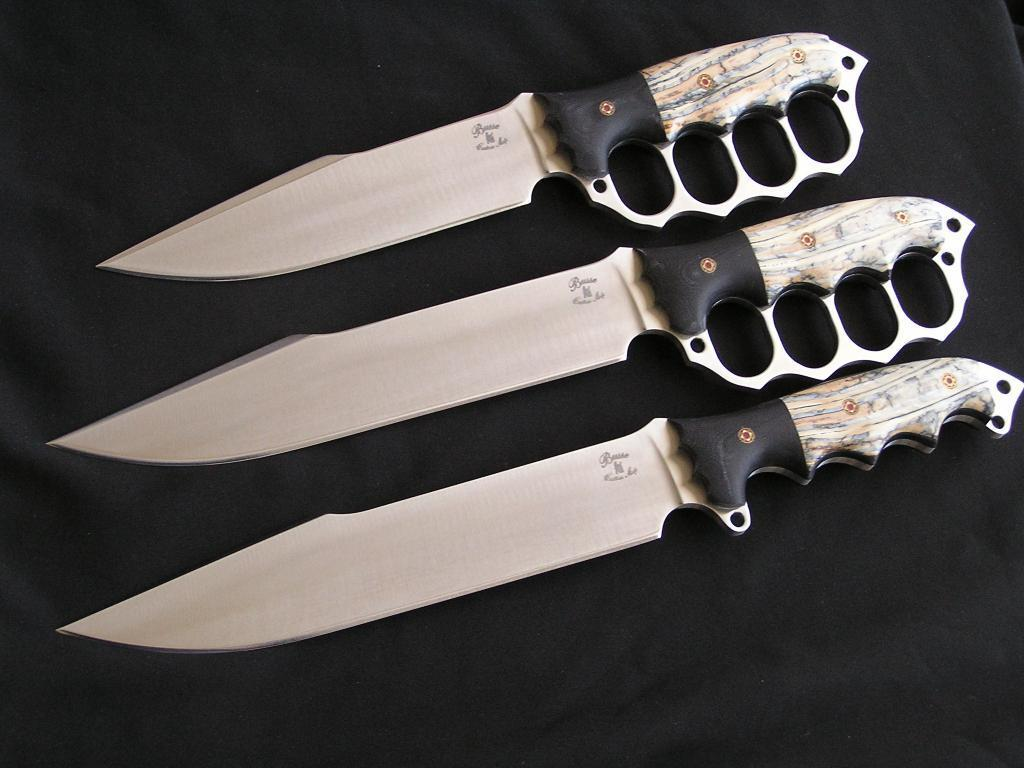How many knives are visible in the image? There are three knives in the image. What feature do two of the knives have? Two of the knives have handles. On what surface are the knives placed? The knives are placed on a black cloth. What color is the daughter's hair in the image? There is no daughter present in the image. What material is the copper pot made of in the image? There is no copper pot present in the image. 